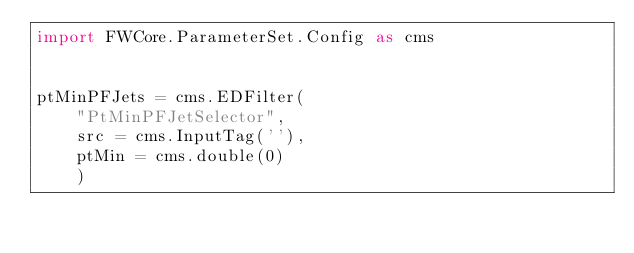Convert code to text. <code><loc_0><loc_0><loc_500><loc_500><_Python_>import FWCore.ParameterSet.Config as cms


ptMinPFJets = cms.EDFilter(
    "PtMinPFJetSelector",
    src = cms.InputTag(''),
    ptMin = cms.double(0)
    )
</code> 